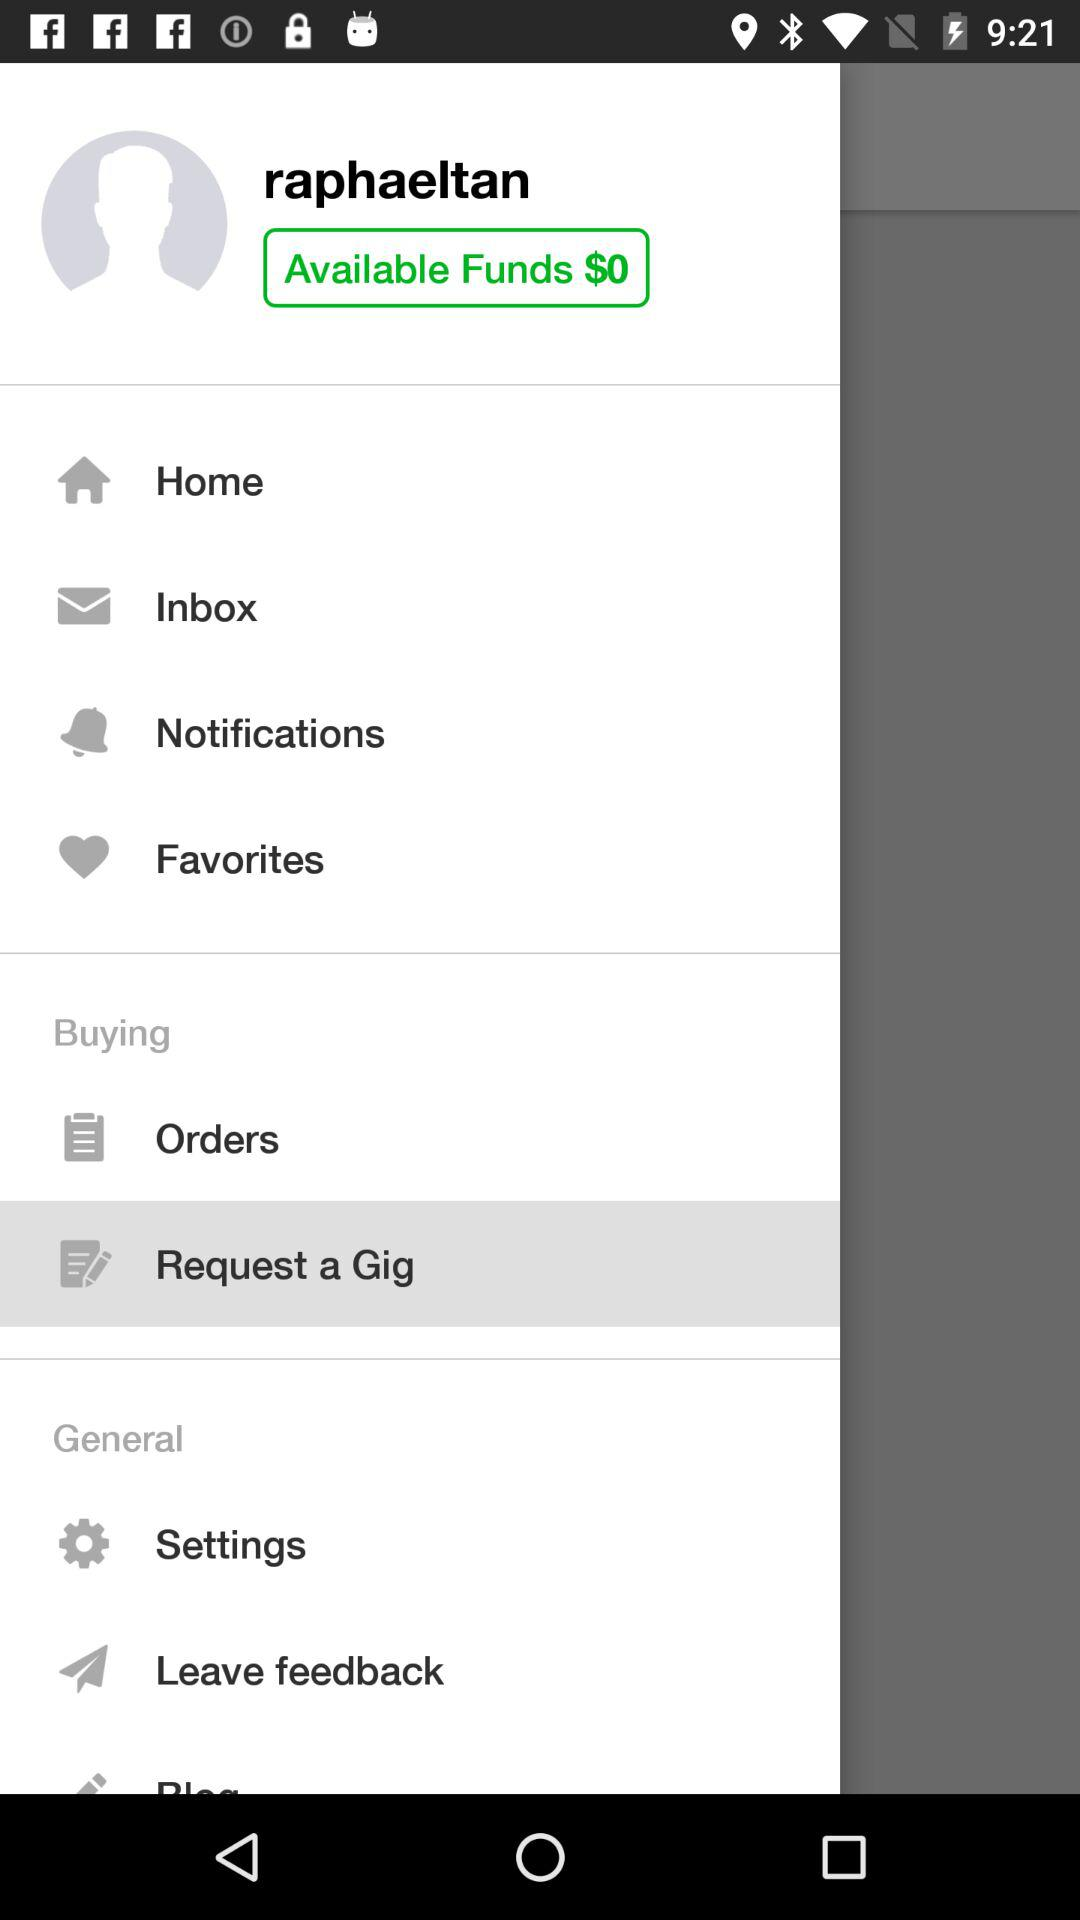Which item is highlighted in the menu? The highlighted item is "Request a Gig". 